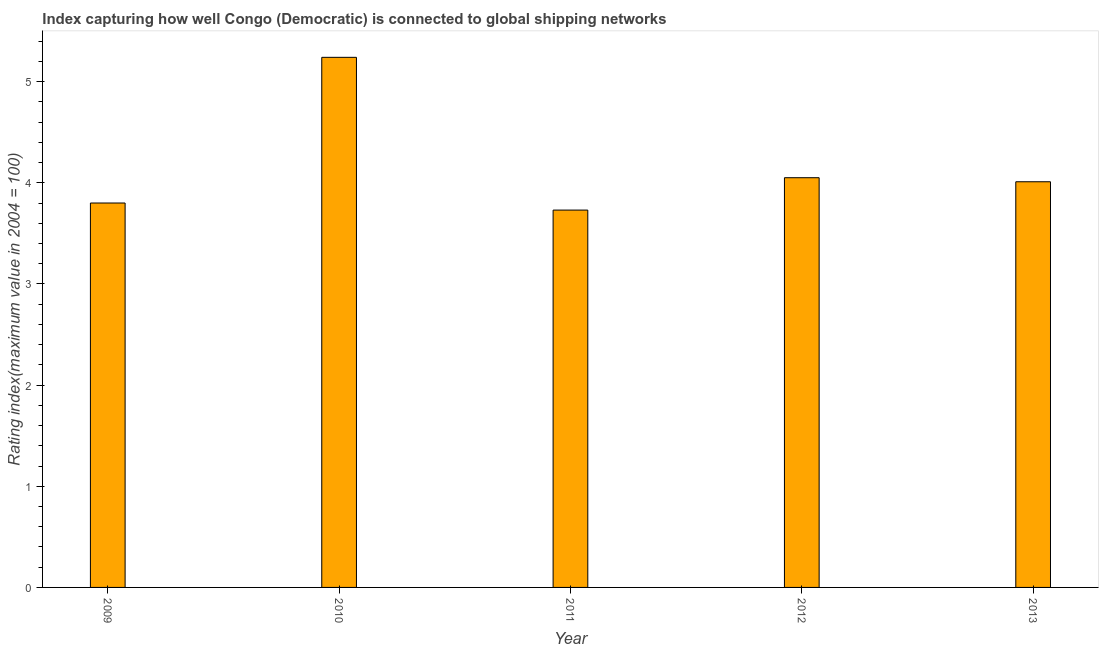What is the title of the graph?
Your answer should be very brief. Index capturing how well Congo (Democratic) is connected to global shipping networks. What is the label or title of the Y-axis?
Keep it short and to the point. Rating index(maximum value in 2004 = 100). What is the liner shipping connectivity index in 2011?
Your response must be concise. 3.73. Across all years, what is the maximum liner shipping connectivity index?
Make the answer very short. 5.24. Across all years, what is the minimum liner shipping connectivity index?
Provide a short and direct response. 3.73. What is the sum of the liner shipping connectivity index?
Give a very brief answer. 20.83. What is the difference between the liner shipping connectivity index in 2011 and 2012?
Keep it short and to the point. -0.32. What is the average liner shipping connectivity index per year?
Make the answer very short. 4.17. What is the median liner shipping connectivity index?
Offer a very short reply. 4.01. In how many years, is the liner shipping connectivity index greater than 4 ?
Offer a very short reply. 3. What is the difference between the highest and the second highest liner shipping connectivity index?
Offer a very short reply. 1.19. What is the difference between the highest and the lowest liner shipping connectivity index?
Your answer should be compact. 1.51. In how many years, is the liner shipping connectivity index greater than the average liner shipping connectivity index taken over all years?
Ensure brevity in your answer.  1. How many bars are there?
Your response must be concise. 5. Are all the bars in the graph horizontal?
Give a very brief answer. No. How many years are there in the graph?
Provide a succinct answer. 5. What is the difference between two consecutive major ticks on the Y-axis?
Provide a short and direct response. 1. What is the Rating index(maximum value in 2004 = 100) in 2009?
Offer a terse response. 3.8. What is the Rating index(maximum value in 2004 = 100) in 2010?
Offer a terse response. 5.24. What is the Rating index(maximum value in 2004 = 100) in 2011?
Offer a terse response. 3.73. What is the Rating index(maximum value in 2004 = 100) in 2012?
Offer a very short reply. 4.05. What is the Rating index(maximum value in 2004 = 100) of 2013?
Offer a very short reply. 4.01. What is the difference between the Rating index(maximum value in 2004 = 100) in 2009 and 2010?
Make the answer very short. -1.44. What is the difference between the Rating index(maximum value in 2004 = 100) in 2009 and 2011?
Offer a terse response. 0.07. What is the difference between the Rating index(maximum value in 2004 = 100) in 2009 and 2012?
Offer a terse response. -0.25. What is the difference between the Rating index(maximum value in 2004 = 100) in 2009 and 2013?
Your response must be concise. -0.21. What is the difference between the Rating index(maximum value in 2004 = 100) in 2010 and 2011?
Offer a terse response. 1.51. What is the difference between the Rating index(maximum value in 2004 = 100) in 2010 and 2012?
Provide a short and direct response. 1.19. What is the difference between the Rating index(maximum value in 2004 = 100) in 2010 and 2013?
Ensure brevity in your answer.  1.23. What is the difference between the Rating index(maximum value in 2004 = 100) in 2011 and 2012?
Your answer should be compact. -0.32. What is the difference between the Rating index(maximum value in 2004 = 100) in 2011 and 2013?
Provide a short and direct response. -0.28. What is the ratio of the Rating index(maximum value in 2004 = 100) in 2009 to that in 2010?
Give a very brief answer. 0.72. What is the ratio of the Rating index(maximum value in 2004 = 100) in 2009 to that in 2012?
Offer a very short reply. 0.94. What is the ratio of the Rating index(maximum value in 2004 = 100) in 2009 to that in 2013?
Offer a very short reply. 0.95. What is the ratio of the Rating index(maximum value in 2004 = 100) in 2010 to that in 2011?
Provide a succinct answer. 1.41. What is the ratio of the Rating index(maximum value in 2004 = 100) in 2010 to that in 2012?
Keep it short and to the point. 1.29. What is the ratio of the Rating index(maximum value in 2004 = 100) in 2010 to that in 2013?
Keep it short and to the point. 1.31. What is the ratio of the Rating index(maximum value in 2004 = 100) in 2011 to that in 2012?
Keep it short and to the point. 0.92. What is the ratio of the Rating index(maximum value in 2004 = 100) in 2011 to that in 2013?
Keep it short and to the point. 0.93. 